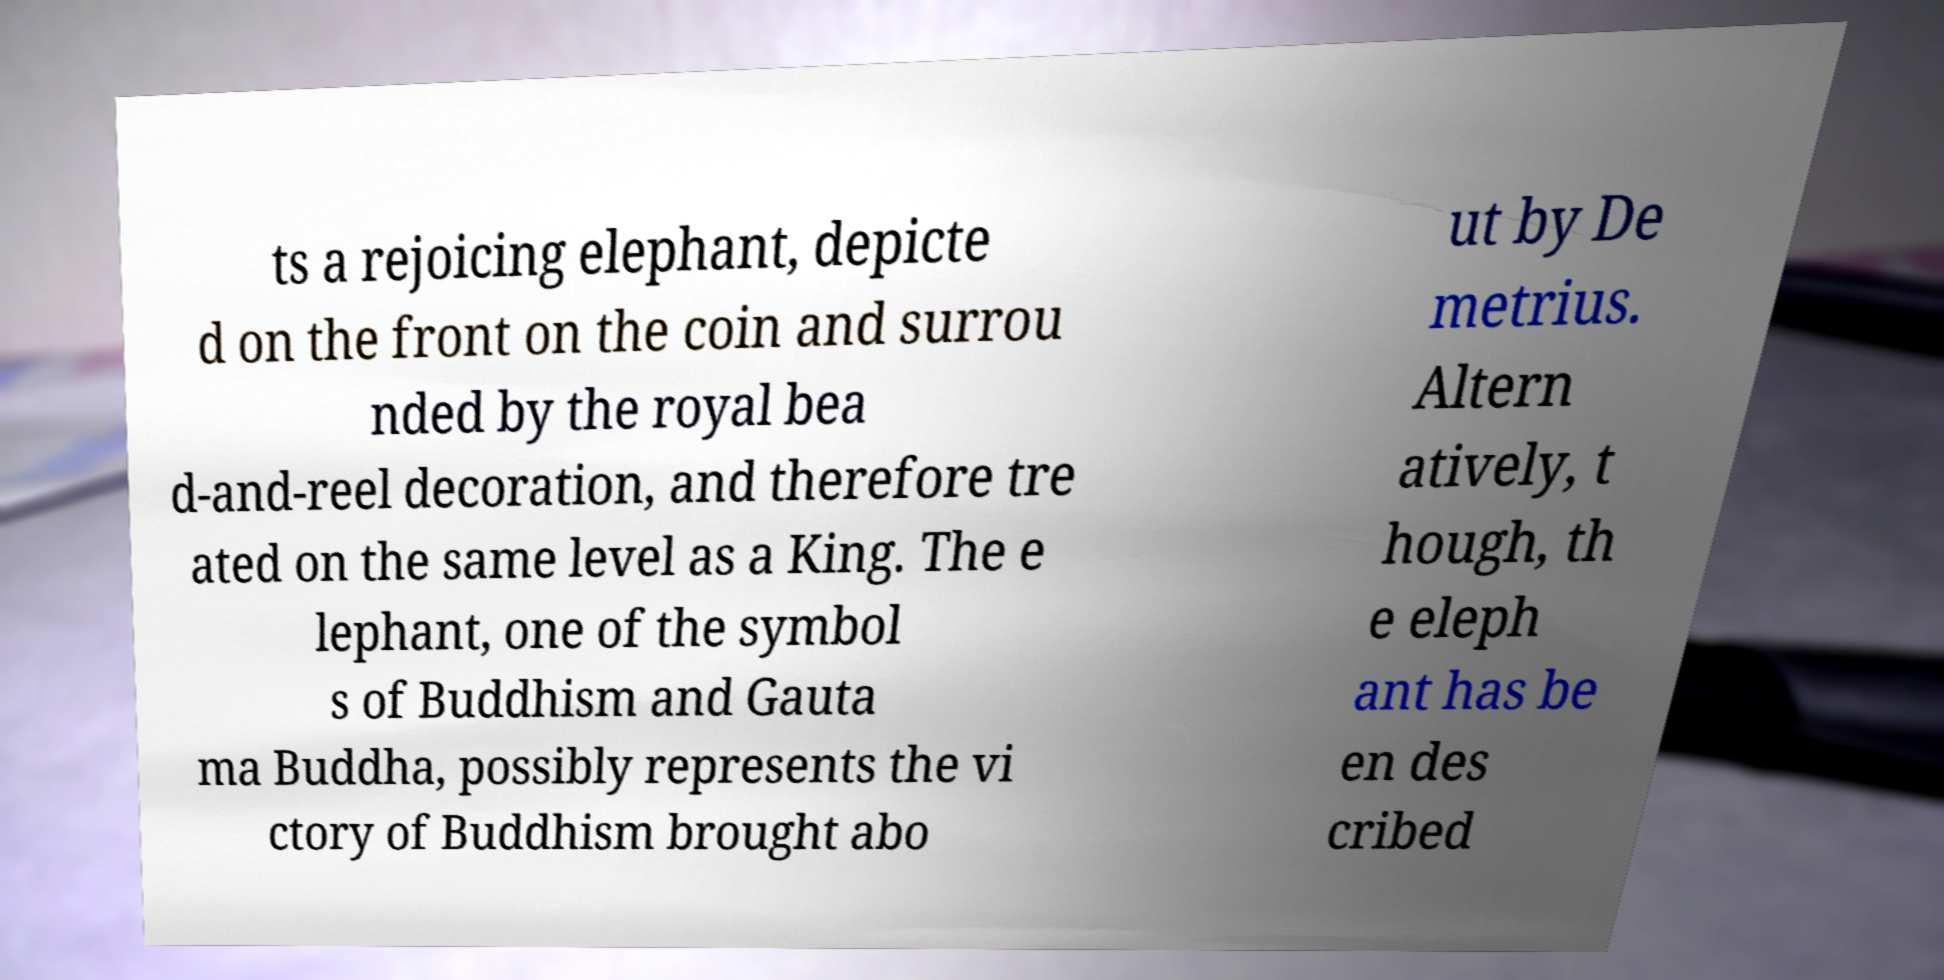Please identify and transcribe the text found in this image. ts a rejoicing elephant, depicte d on the front on the coin and surrou nded by the royal bea d-and-reel decoration, and therefore tre ated on the same level as a King. The e lephant, one of the symbol s of Buddhism and Gauta ma Buddha, possibly represents the vi ctory of Buddhism brought abo ut by De metrius. Altern atively, t hough, th e eleph ant has be en des cribed 